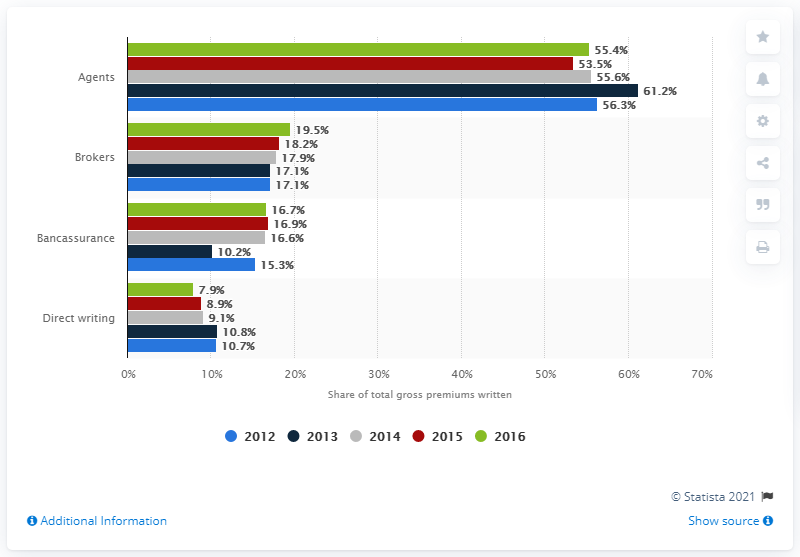Highlight a few significant elements in this photo. In 2016, agents in Portugal represented 55.6% of the total insurance sales. 